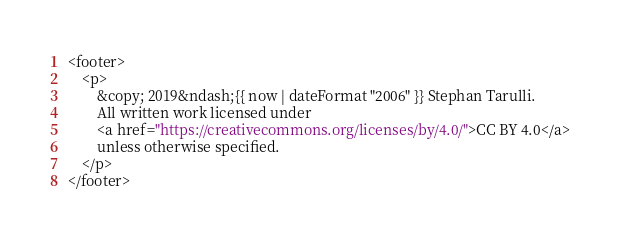<code> <loc_0><loc_0><loc_500><loc_500><_HTML_><footer>
    <p>
        &copy; 2019&ndash;{{ now | dateFormat "2006" }} Stephan Tarulli.
        All written work licensed under
        <a href="https://creativecommons.org/licenses/by/4.0/">CC BY 4.0</a>
        unless otherwise specified.
    </p>
</footer>
</code> 